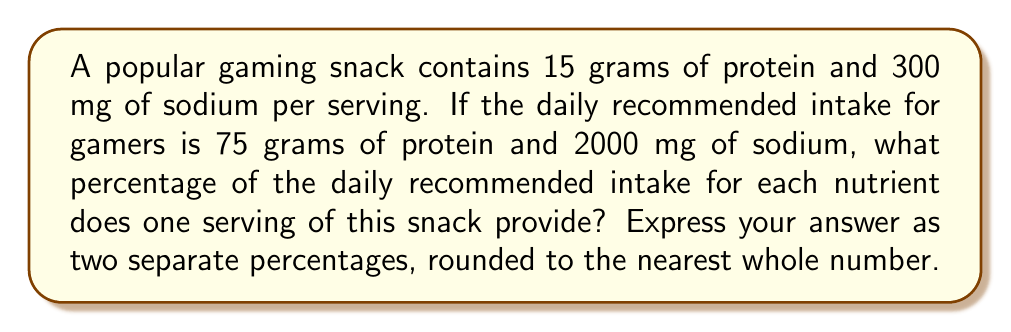Can you solve this math problem? To solve this problem, we need to calculate the percentage of daily recommended intake for both protein and sodium separately. Let's break it down step by step:

1. For protein:
   * Amount in snack: 15 grams
   * Daily recommended intake: 75 grams
   * Percentage calculation: $\frac{\text{amount in snack}}{\text{daily recommended intake}} \times 100\%$
   * $\frac{15}{75} \times 100\% = 0.2 \times 100\% = 20\%$

2. For sodium:
   * Amount in snack: 300 mg
   * Daily recommended intake: 2000 mg
   * Percentage calculation: $\frac{\text{amount in snack}}{\text{daily recommended intake}} \times 100\%$
   * $\frac{300}{2000} \times 100\% = 0.15 \times 100\% = 15\%$

Therefore, one serving of this gaming snack provides:
* 20% of the daily recommended protein intake
* 15% of the daily recommended sodium intake

Both percentages are already whole numbers, so no rounding is necessary.
Answer: Protein: 20%, Sodium: 15% 